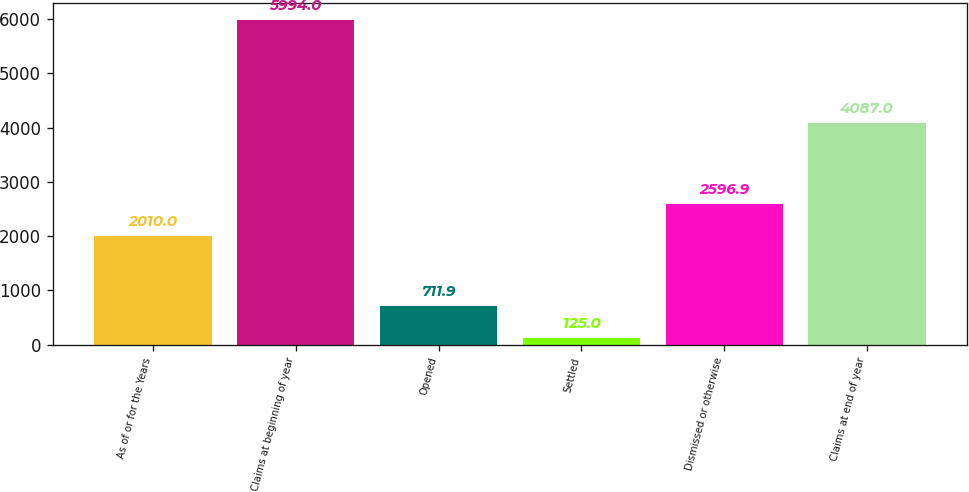Convert chart. <chart><loc_0><loc_0><loc_500><loc_500><bar_chart><fcel>As of or for the Years<fcel>Claims at beginning of year<fcel>Opened<fcel>Settled<fcel>Dismissed or otherwise<fcel>Claims at end of year<nl><fcel>2010<fcel>5994<fcel>711.9<fcel>125<fcel>2596.9<fcel>4087<nl></chart> 